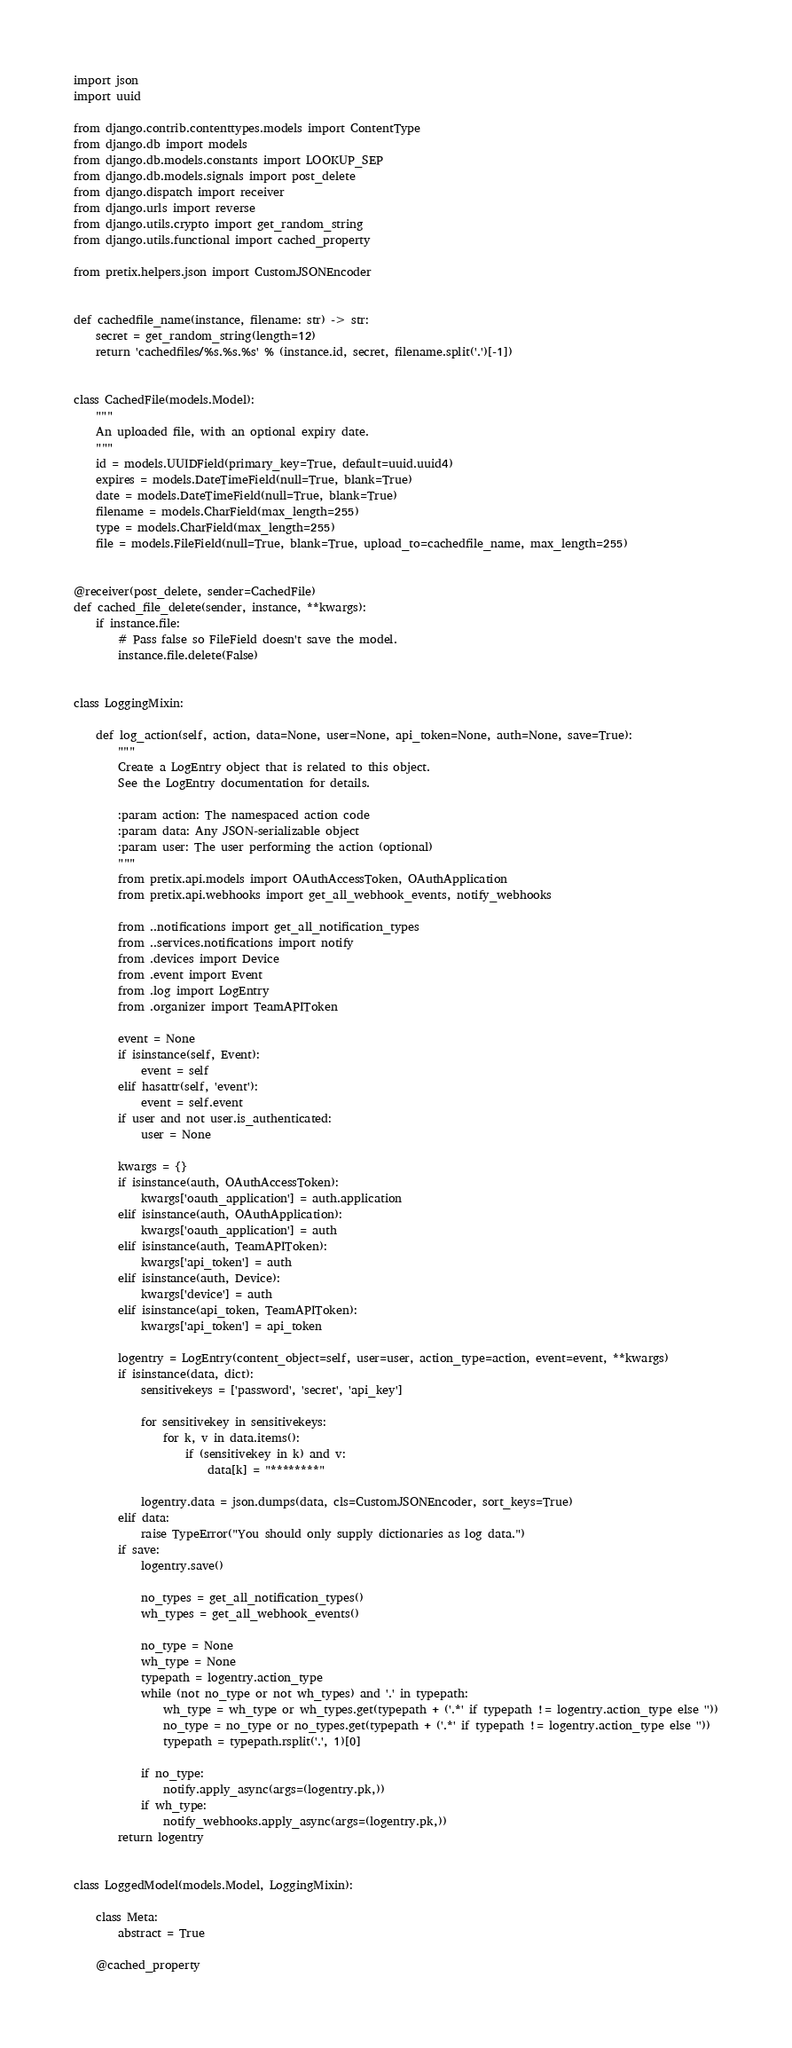Convert code to text. <code><loc_0><loc_0><loc_500><loc_500><_Python_>import json
import uuid

from django.contrib.contenttypes.models import ContentType
from django.db import models
from django.db.models.constants import LOOKUP_SEP
from django.db.models.signals import post_delete
from django.dispatch import receiver
from django.urls import reverse
from django.utils.crypto import get_random_string
from django.utils.functional import cached_property

from pretix.helpers.json import CustomJSONEncoder


def cachedfile_name(instance, filename: str) -> str:
    secret = get_random_string(length=12)
    return 'cachedfiles/%s.%s.%s' % (instance.id, secret, filename.split('.')[-1])


class CachedFile(models.Model):
    """
    An uploaded file, with an optional expiry date.
    """
    id = models.UUIDField(primary_key=True, default=uuid.uuid4)
    expires = models.DateTimeField(null=True, blank=True)
    date = models.DateTimeField(null=True, blank=True)
    filename = models.CharField(max_length=255)
    type = models.CharField(max_length=255)
    file = models.FileField(null=True, blank=True, upload_to=cachedfile_name, max_length=255)


@receiver(post_delete, sender=CachedFile)
def cached_file_delete(sender, instance, **kwargs):
    if instance.file:
        # Pass false so FileField doesn't save the model.
        instance.file.delete(False)


class LoggingMixin:

    def log_action(self, action, data=None, user=None, api_token=None, auth=None, save=True):
        """
        Create a LogEntry object that is related to this object.
        See the LogEntry documentation for details.

        :param action: The namespaced action code
        :param data: Any JSON-serializable object
        :param user: The user performing the action (optional)
        """
        from pretix.api.models import OAuthAccessToken, OAuthApplication
        from pretix.api.webhooks import get_all_webhook_events, notify_webhooks

        from ..notifications import get_all_notification_types
        from ..services.notifications import notify
        from .devices import Device
        from .event import Event
        from .log import LogEntry
        from .organizer import TeamAPIToken

        event = None
        if isinstance(self, Event):
            event = self
        elif hasattr(self, 'event'):
            event = self.event
        if user and not user.is_authenticated:
            user = None

        kwargs = {}
        if isinstance(auth, OAuthAccessToken):
            kwargs['oauth_application'] = auth.application
        elif isinstance(auth, OAuthApplication):
            kwargs['oauth_application'] = auth
        elif isinstance(auth, TeamAPIToken):
            kwargs['api_token'] = auth
        elif isinstance(auth, Device):
            kwargs['device'] = auth
        elif isinstance(api_token, TeamAPIToken):
            kwargs['api_token'] = api_token

        logentry = LogEntry(content_object=self, user=user, action_type=action, event=event, **kwargs)
        if isinstance(data, dict):
            sensitivekeys = ['password', 'secret', 'api_key']

            for sensitivekey in sensitivekeys:
                for k, v in data.items():
                    if (sensitivekey in k) and v:
                        data[k] = "********"

            logentry.data = json.dumps(data, cls=CustomJSONEncoder, sort_keys=True)
        elif data:
            raise TypeError("You should only supply dictionaries as log data.")
        if save:
            logentry.save()

            no_types = get_all_notification_types()
            wh_types = get_all_webhook_events()

            no_type = None
            wh_type = None
            typepath = logentry.action_type
            while (not no_type or not wh_types) and '.' in typepath:
                wh_type = wh_type or wh_types.get(typepath + ('.*' if typepath != logentry.action_type else ''))
                no_type = no_type or no_types.get(typepath + ('.*' if typepath != logentry.action_type else ''))
                typepath = typepath.rsplit('.', 1)[0]

            if no_type:
                notify.apply_async(args=(logentry.pk,))
            if wh_type:
                notify_webhooks.apply_async(args=(logentry.pk,))
        return logentry


class LoggedModel(models.Model, LoggingMixin):

    class Meta:
        abstract = True

    @cached_property</code> 